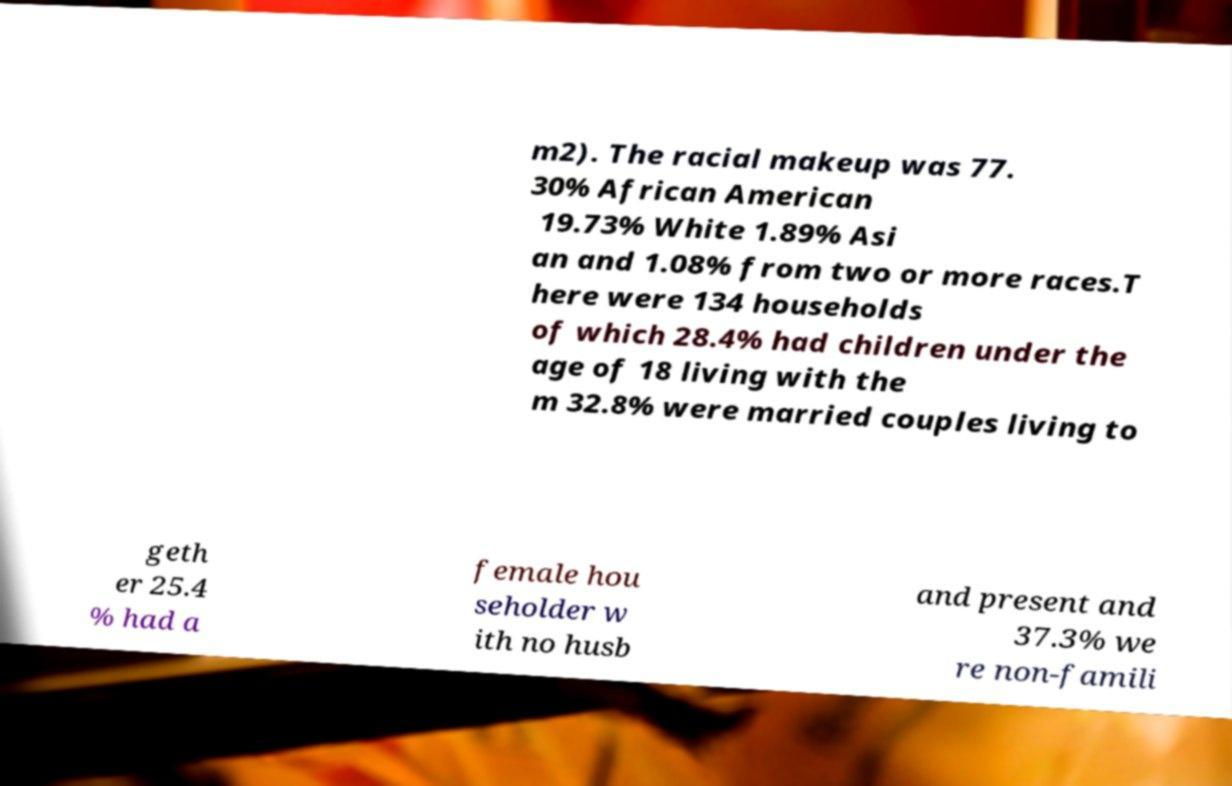Could you extract and type out the text from this image? m2). The racial makeup was 77. 30% African American 19.73% White 1.89% Asi an and 1.08% from two or more races.T here were 134 households of which 28.4% had children under the age of 18 living with the m 32.8% were married couples living to geth er 25.4 % had a female hou seholder w ith no husb and present and 37.3% we re non-famili 